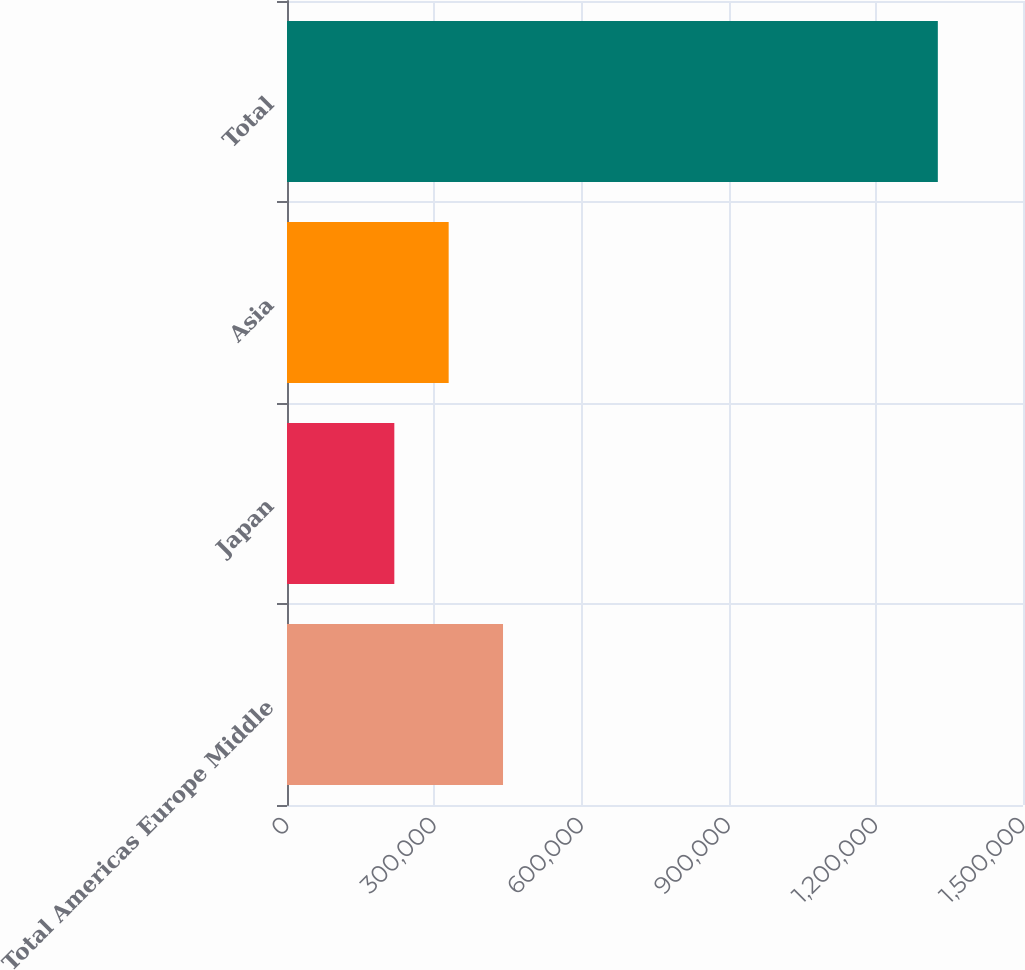<chart> <loc_0><loc_0><loc_500><loc_500><bar_chart><fcel>Total Americas Europe Middle<fcel>Japan<fcel>Asia<fcel>Total<nl><fcel>440270<fcel>218731<fcel>329500<fcel>1.32642e+06<nl></chart> 